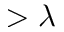Convert formula to latex. <formula><loc_0><loc_0><loc_500><loc_500>> \lambda</formula> 